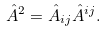Convert formula to latex. <formula><loc_0><loc_0><loc_500><loc_500>\hat { A } ^ { 2 } = \hat { A } _ { i j } \hat { A } ^ { i j } .</formula> 